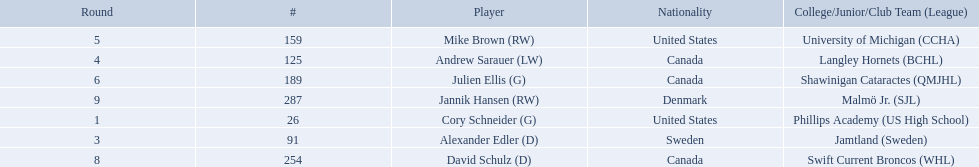Which players have canadian nationality? Andrew Sarauer (LW), Julien Ellis (G), David Schulz (D). Of those, which attended langley hornets? Andrew Sarauer (LW). 